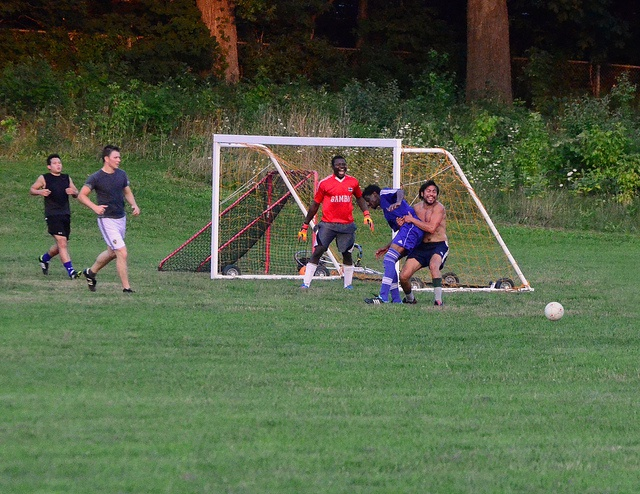Describe the objects in this image and their specific colors. I can see people in black, gray, and red tones, people in black, lightpink, navy, and gray tones, people in black, brown, gray, and darkgray tones, people in black, darkblue, navy, and blue tones, and people in black, gray, lightpink, and brown tones in this image. 